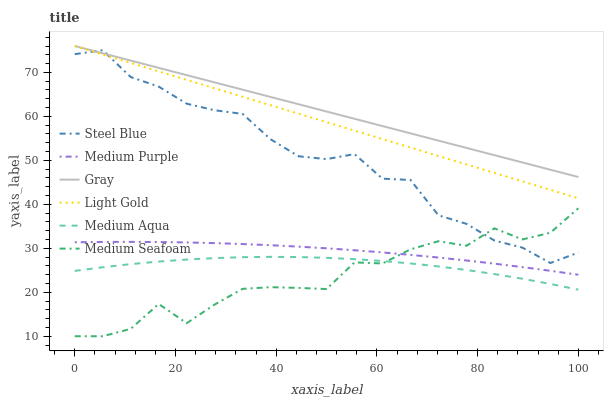Does Medium Seafoam have the minimum area under the curve?
Answer yes or no. Yes. Does Gray have the maximum area under the curve?
Answer yes or no. Yes. Does Steel Blue have the minimum area under the curve?
Answer yes or no. No. Does Steel Blue have the maximum area under the curve?
Answer yes or no. No. Is Light Gold the smoothest?
Answer yes or no. Yes. Is Medium Seafoam the roughest?
Answer yes or no. Yes. Is Steel Blue the smoothest?
Answer yes or no. No. Is Steel Blue the roughest?
Answer yes or no. No. Does Medium Seafoam have the lowest value?
Answer yes or no. Yes. Does Steel Blue have the lowest value?
Answer yes or no. No. Does Light Gold have the highest value?
Answer yes or no. Yes. Does Steel Blue have the highest value?
Answer yes or no. No. Is Medium Seafoam less than Light Gold?
Answer yes or no. Yes. Is Light Gold greater than Medium Aqua?
Answer yes or no. Yes. Does Light Gold intersect Steel Blue?
Answer yes or no. Yes. Is Light Gold less than Steel Blue?
Answer yes or no. No. Is Light Gold greater than Steel Blue?
Answer yes or no. No. Does Medium Seafoam intersect Light Gold?
Answer yes or no. No. 